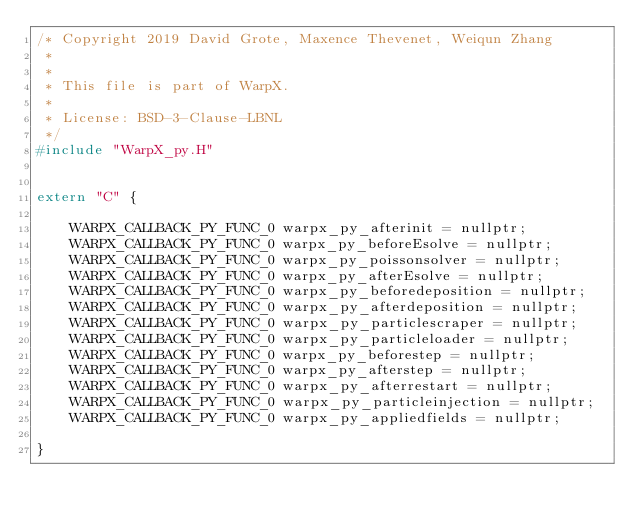Convert code to text. <code><loc_0><loc_0><loc_500><loc_500><_C++_>/* Copyright 2019 David Grote, Maxence Thevenet, Weiqun Zhang
 *
 *
 * This file is part of WarpX.
 *
 * License: BSD-3-Clause-LBNL
 */
#include "WarpX_py.H"


extern "C" {

    WARPX_CALLBACK_PY_FUNC_0 warpx_py_afterinit = nullptr;
    WARPX_CALLBACK_PY_FUNC_0 warpx_py_beforeEsolve = nullptr;
    WARPX_CALLBACK_PY_FUNC_0 warpx_py_poissonsolver = nullptr;
    WARPX_CALLBACK_PY_FUNC_0 warpx_py_afterEsolve = nullptr;
    WARPX_CALLBACK_PY_FUNC_0 warpx_py_beforedeposition = nullptr;
    WARPX_CALLBACK_PY_FUNC_0 warpx_py_afterdeposition = nullptr;
    WARPX_CALLBACK_PY_FUNC_0 warpx_py_particlescraper = nullptr;
    WARPX_CALLBACK_PY_FUNC_0 warpx_py_particleloader = nullptr;
    WARPX_CALLBACK_PY_FUNC_0 warpx_py_beforestep = nullptr;
    WARPX_CALLBACK_PY_FUNC_0 warpx_py_afterstep = nullptr;
    WARPX_CALLBACK_PY_FUNC_0 warpx_py_afterrestart = nullptr;
    WARPX_CALLBACK_PY_FUNC_0 warpx_py_particleinjection = nullptr;
    WARPX_CALLBACK_PY_FUNC_0 warpx_py_appliedfields = nullptr;

}

</code> 